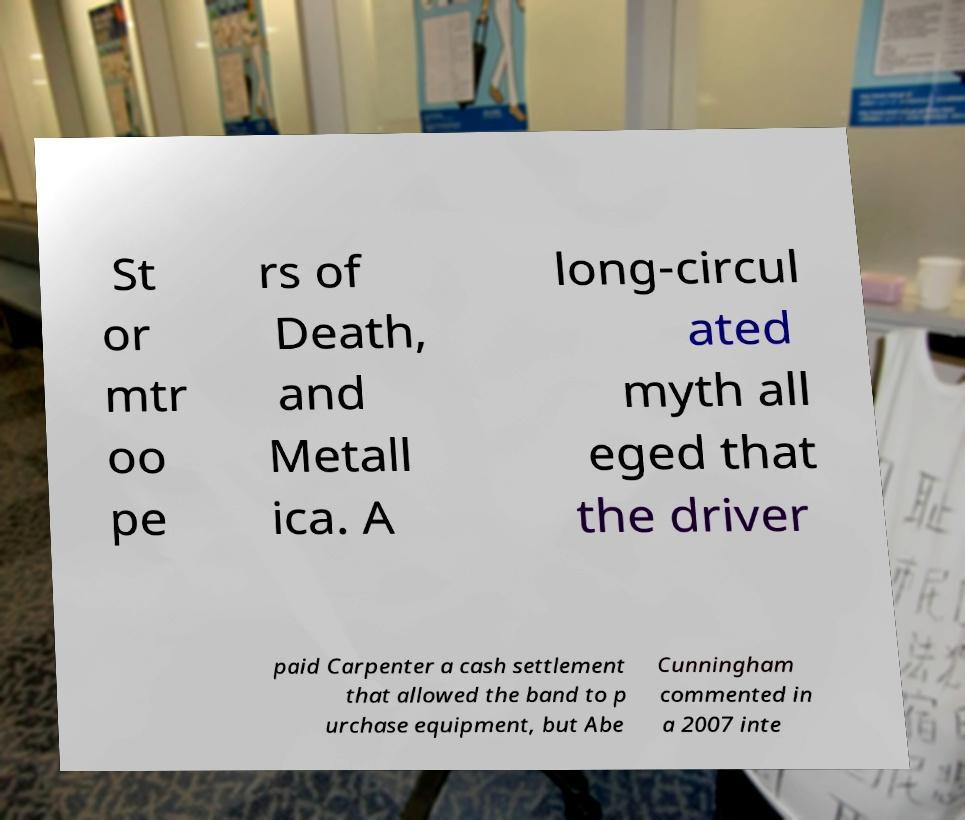What messages or text are displayed in this image? I need them in a readable, typed format. St or mtr oo pe rs of Death, and Metall ica. A long-circul ated myth all eged that the driver paid Carpenter a cash settlement that allowed the band to p urchase equipment, but Abe Cunningham commented in a 2007 inte 